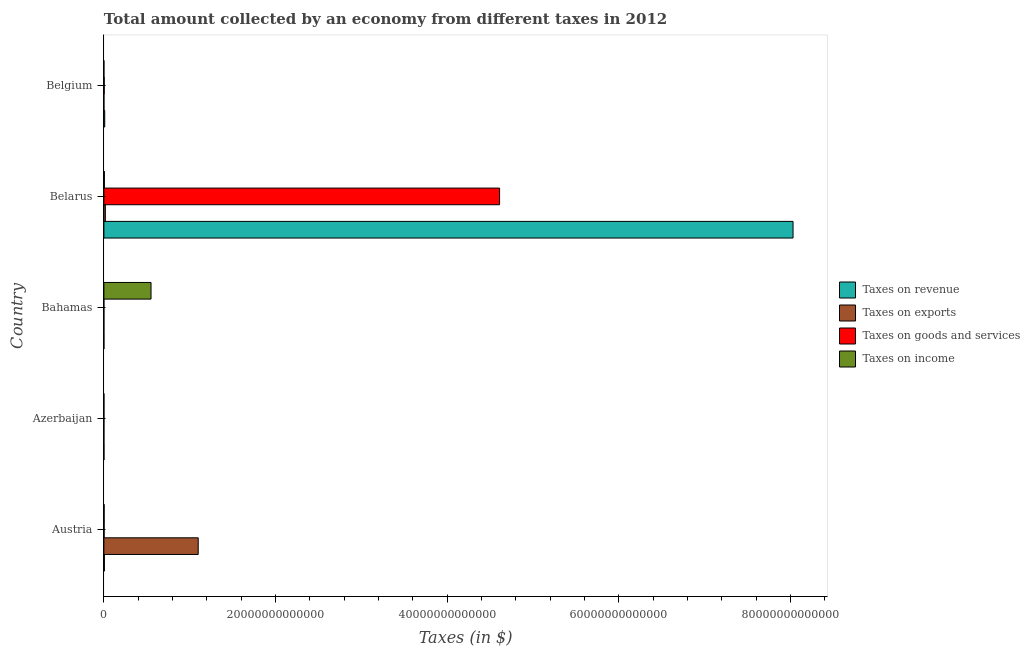How many different coloured bars are there?
Offer a very short reply. 4. What is the label of the 3rd group of bars from the top?
Provide a succinct answer. Bahamas. What is the amount collected as tax on goods in Belgium?
Offer a terse response. 3.81e+1. Across all countries, what is the maximum amount collected as tax on revenue?
Offer a terse response. 8.03e+13. Across all countries, what is the minimum amount collected as tax on exports?
Give a very brief answer. 2.26e+06. In which country was the amount collected as tax on revenue maximum?
Provide a succinct answer. Belarus. In which country was the amount collected as tax on revenue minimum?
Offer a very short reply. Bahamas. What is the total amount collected as tax on exports in the graph?
Your response must be concise. 1.12e+13. What is the difference between the amount collected as tax on revenue in Belarus and that in Belgium?
Your answer should be very brief. 8.02e+13. What is the difference between the amount collected as tax on income in Austria and the amount collected as tax on revenue in Bahamas?
Ensure brevity in your answer.  2.57e+1. What is the average amount collected as tax on revenue per country?
Make the answer very short. 1.61e+13. What is the difference between the amount collected as tax on exports and amount collected as tax on goods in Belarus?
Offer a very short reply. -4.59e+13. In how many countries, is the amount collected as tax on revenue greater than 72000000000000 $?
Offer a terse response. 1. What is the ratio of the amount collected as tax on income in Austria to that in Belarus?
Ensure brevity in your answer.  0.48. What is the difference between the highest and the second highest amount collected as tax on goods?
Your answer should be compact. 4.61e+13. What is the difference between the highest and the lowest amount collected as tax on exports?
Offer a very short reply. 1.10e+13. In how many countries, is the amount collected as tax on goods greater than the average amount collected as tax on goods taken over all countries?
Your answer should be compact. 1. Is the sum of the amount collected as tax on income in Bahamas and Belgium greater than the maximum amount collected as tax on exports across all countries?
Ensure brevity in your answer.  No. Is it the case that in every country, the sum of the amount collected as tax on revenue and amount collected as tax on goods is greater than the sum of amount collected as tax on income and amount collected as tax on exports?
Keep it short and to the point. No. What does the 1st bar from the top in Bahamas represents?
Make the answer very short. Taxes on income. What does the 4th bar from the bottom in Azerbaijan represents?
Offer a very short reply. Taxes on income. Is it the case that in every country, the sum of the amount collected as tax on revenue and amount collected as tax on exports is greater than the amount collected as tax on goods?
Provide a short and direct response. Yes. How many countries are there in the graph?
Provide a succinct answer. 5. What is the difference between two consecutive major ticks on the X-axis?
Provide a short and direct response. 2.00e+13. Does the graph contain any zero values?
Provide a short and direct response. No. Does the graph contain grids?
Your answer should be very brief. No. How many legend labels are there?
Make the answer very short. 4. How are the legend labels stacked?
Ensure brevity in your answer.  Vertical. What is the title of the graph?
Ensure brevity in your answer.  Total amount collected by an economy from different taxes in 2012. Does "Social Protection" appear as one of the legend labels in the graph?
Provide a short and direct response. No. What is the label or title of the X-axis?
Make the answer very short. Taxes (in $). What is the Taxes (in $) of Taxes on revenue in Austria?
Provide a succinct answer. 5.79e+1. What is the Taxes (in $) in Taxes on exports in Austria?
Ensure brevity in your answer.  1.10e+13. What is the Taxes (in $) in Taxes on goods and services in Austria?
Make the answer very short. 2.54e+1. What is the Taxes (in $) in Taxes on income in Austria?
Offer a terse response. 2.70e+1. What is the Taxes (in $) in Taxes on revenue in Azerbaijan?
Provide a succinct answer. 7.00e+09. What is the Taxes (in $) of Taxes on exports in Azerbaijan?
Ensure brevity in your answer.  4.79e+08. What is the Taxes (in $) of Taxes on goods and services in Azerbaijan?
Keep it short and to the point. 3.08e+09. What is the Taxes (in $) in Taxes on income in Azerbaijan?
Keep it short and to the point. 3.07e+09. What is the Taxes (in $) in Taxes on revenue in Bahamas?
Keep it short and to the point. 1.28e+09. What is the Taxes (in $) in Taxes on exports in Bahamas?
Your response must be concise. 2.26e+06. What is the Taxes (in $) in Taxes on goods and services in Bahamas?
Ensure brevity in your answer.  2.09e+08. What is the Taxes (in $) of Taxes on income in Bahamas?
Give a very brief answer. 5.49e+12. What is the Taxes (in $) of Taxes on revenue in Belarus?
Give a very brief answer. 8.03e+13. What is the Taxes (in $) of Taxes on exports in Belarus?
Your answer should be compact. 1.69e+11. What is the Taxes (in $) in Taxes on goods and services in Belarus?
Offer a very short reply. 4.61e+13. What is the Taxes (in $) of Taxes on income in Belarus?
Your answer should be compact. 5.65e+1. What is the Taxes (in $) of Taxes on revenue in Belgium?
Ensure brevity in your answer.  9.65e+1. What is the Taxes (in $) in Taxes on exports in Belgium?
Ensure brevity in your answer.  2.23e+09. What is the Taxes (in $) of Taxes on goods and services in Belgium?
Provide a succinct answer. 3.81e+1. What is the Taxes (in $) in Taxes on income in Belgium?
Offer a terse response. 2.42e+08. Across all countries, what is the maximum Taxes (in $) of Taxes on revenue?
Provide a succinct answer. 8.03e+13. Across all countries, what is the maximum Taxes (in $) in Taxes on exports?
Keep it short and to the point. 1.10e+13. Across all countries, what is the maximum Taxes (in $) of Taxes on goods and services?
Your answer should be compact. 4.61e+13. Across all countries, what is the maximum Taxes (in $) in Taxes on income?
Your answer should be compact. 5.49e+12. Across all countries, what is the minimum Taxes (in $) of Taxes on revenue?
Offer a very short reply. 1.28e+09. Across all countries, what is the minimum Taxes (in $) in Taxes on exports?
Your answer should be very brief. 2.26e+06. Across all countries, what is the minimum Taxes (in $) of Taxes on goods and services?
Your answer should be very brief. 2.09e+08. Across all countries, what is the minimum Taxes (in $) of Taxes on income?
Offer a terse response. 2.42e+08. What is the total Taxes (in $) of Taxes on revenue in the graph?
Give a very brief answer. 8.05e+13. What is the total Taxes (in $) in Taxes on exports in the graph?
Offer a terse response. 1.12e+13. What is the total Taxes (in $) in Taxes on goods and services in the graph?
Provide a short and direct response. 4.62e+13. What is the total Taxes (in $) in Taxes on income in the graph?
Your answer should be very brief. 5.58e+12. What is the difference between the Taxes (in $) in Taxes on revenue in Austria and that in Azerbaijan?
Ensure brevity in your answer.  5.10e+1. What is the difference between the Taxes (in $) of Taxes on exports in Austria and that in Azerbaijan?
Offer a very short reply. 1.10e+13. What is the difference between the Taxes (in $) in Taxes on goods and services in Austria and that in Azerbaijan?
Provide a succinct answer. 2.23e+1. What is the difference between the Taxes (in $) of Taxes on income in Austria and that in Azerbaijan?
Provide a succinct answer. 2.40e+1. What is the difference between the Taxes (in $) in Taxes on revenue in Austria and that in Bahamas?
Your response must be concise. 5.67e+1. What is the difference between the Taxes (in $) of Taxes on exports in Austria and that in Bahamas?
Provide a succinct answer. 1.10e+13. What is the difference between the Taxes (in $) in Taxes on goods and services in Austria and that in Bahamas?
Your response must be concise. 2.52e+1. What is the difference between the Taxes (in $) of Taxes on income in Austria and that in Bahamas?
Your response must be concise. -5.46e+12. What is the difference between the Taxes (in $) of Taxes on revenue in Austria and that in Belarus?
Provide a short and direct response. -8.02e+13. What is the difference between the Taxes (in $) of Taxes on exports in Austria and that in Belarus?
Provide a succinct answer. 1.08e+13. What is the difference between the Taxes (in $) in Taxes on goods and services in Austria and that in Belarus?
Provide a succinct answer. -4.61e+13. What is the difference between the Taxes (in $) of Taxes on income in Austria and that in Belarus?
Provide a succinct answer. -2.95e+1. What is the difference between the Taxes (in $) in Taxes on revenue in Austria and that in Belgium?
Make the answer very short. -3.86e+1. What is the difference between the Taxes (in $) in Taxes on exports in Austria and that in Belgium?
Your answer should be very brief. 1.10e+13. What is the difference between the Taxes (in $) of Taxes on goods and services in Austria and that in Belgium?
Offer a terse response. -1.27e+1. What is the difference between the Taxes (in $) in Taxes on income in Austria and that in Belgium?
Provide a succinct answer. 2.68e+1. What is the difference between the Taxes (in $) of Taxes on revenue in Azerbaijan and that in Bahamas?
Your response must be concise. 5.72e+09. What is the difference between the Taxes (in $) in Taxes on exports in Azerbaijan and that in Bahamas?
Keep it short and to the point. 4.77e+08. What is the difference between the Taxes (in $) of Taxes on goods and services in Azerbaijan and that in Bahamas?
Offer a very short reply. 2.87e+09. What is the difference between the Taxes (in $) in Taxes on income in Azerbaijan and that in Bahamas?
Provide a short and direct response. -5.49e+12. What is the difference between the Taxes (in $) of Taxes on revenue in Azerbaijan and that in Belarus?
Provide a succinct answer. -8.03e+13. What is the difference between the Taxes (in $) of Taxes on exports in Azerbaijan and that in Belarus?
Offer a terse response. -1.69e+11. What is the difference between the Taxes (in $) in Taxes on goods and services in Azerbaijan and that in Belarus?
Offer a terse response. -4.61e+13. What is the difference between the Taxes (in $) in Taxes on income in Azerbaijan and that in Belarus?
Give a very brief answer. -5.35e+1. What is the difference between the Taxes (in $) in Taxes on revenue in Azerbaijan and that in Belgium?
Offer a very short reply. -8.95e+1. What is the difference between the Taxes (in $) of Taxes on exports in Azerbaijan and that in Belgium?
Your answer should be very brief. -1.75e+09. What is the difference between the Taxes (in $) of Taxes on goods and services in Azerbaijan and that in Belgium?
Offer a terse response. -3.51e+1. What is the difference between the Taxes (in $) of Taxes on income in Azerbaijan and that in Belgium?
Offer a terse response. 2.83e+09. What is the difference between the Taxes (in $) of Taxes on revenue in Bahamas and that in Belarus?
Give a very brief answer. -8.03e+13. What is the difference between the Taxes (in $) of Taxes on exports in Bahamas and that in Belarus?
Offer a very short reply. -1.69e+11. What is the difference between the Taxes (in $) of Taxes on goods and services in Bahamas and that in Belarus?
Your response must be concise. -4.61e+13. What is the difference between the Taxes (in $) in Taxes on income in Bahamas and that in Belarus?
Your answer should be very brief. 5.44e+12. What is the difference between the Taxes (in $) of Taxes on revenue in Bahamas and that in Belgium?
Offer a very short reply. -9.52e+1. What is the difference between the Taxes (in $) of Taxes on exports in Bahamas and that in Belgium?
Provide a succinct answer. -2.22e+09. What is the difference between the Taxes (in $) of Taxes on goods and services in Bahamas and that in Belgium?
Offer a terse response. -3.79e+1. What is the difference between the Taxes (in $) of Taxes on income in Bahamas and that in Belgium?
Offer a very short reply. 5.49e+12. What is the difference between the Taxes (in $) in Taxes on revenue in Belarus and that in Belgium?
Provide a succinct answer. 8.02e+13. What is the difference between the Taxes (in $) in Taxes on exports in Belarus and that in Belgium?
Give a very brief answer. 1.67e+11. What is the difference between the Taxes (in $) of Taxes on goods and services in Belarus and that in Belgium?
Your answer should be compact. 4.61e+13. What is the difference between the Taxes (in $) of Taxes on income in Belarus and that in Belgium?
Give a very brief answer. 5.63e+1. What is the difference between the Taxes (in $) in Taxes on revenue in Austria and the Taxes (in $) in Taxes on exports in Azerbaijan?
Give a very brief answer. 5.75e+1. What is the difference between the Taxes (in $) of Taxes on revenue in Austria and the Taxes (in $) of Taxes on goods and services in Azerbaijan?
Give a very brief answer. 5.49e+1. What is the difference between the Taxes (in $) in Taxes on revenue in Austria and the Taxes (in $) in Taxes on income in Azerbaijan?
Make the answer very short. 5.49e+1. What is the difference between the Taxes (in $) in Taxes on exports in Austria and the Taxes (in $) in Taxes on goods and services in Azerbaijan?
Provide a short and direct response. 1.10e+13. What is the difference between the Taxes (in $) in Taxes on exports in Austria and the Taxes (in $) in Taxes on income in Azerbaijan?
Offer a very short reply. 1.10e+13. What is the difference between the Taxes (in $) in Taxes on goods and services in Austria and the Taxes (in $) in Taxes on income in Azerbaijan?
Ensure brevity in your answer.  2.23e+1. What is the difference between the Taxes (in $) of Taxes on revenue in Austria and the Taxes (in $) of Taxes on exports in Bahamas?
Your answer should be compact. 5.79e+1. What is the difference between the Taxes (in $) in Taxes on revenue in Austria and the Taxes (in $) in Taxes on goods and services in Bahamas?
Make the answer very short. 5.77e+1. What is the difference between the Taxes (in $) of Taxes on revenue in Austria and the Taxes (in $) of Taxes on income in Bahamas?
Offer a terse response. -5.43e+12. What is the difference between the Taxes (in $) in Taxes on exports in Austria and the Taxes (in $) in Taxes on goods and services in Bahamas?
Make the answer very short. 1.10e+13. What is the difference between the Taxes (in $) of Taxes on exports in Austria and the Taxes (in $) of Taxes on income in Bahamas?
Provide a short and direct response. 5.50e+12. What is the difference between the Taxes (in $) of Taxes on goods and services in Austria and the Taxes (in $) of Taxes on income in Bahamas?
Make the answer very short. -5.47e+12. What is the difference between the Taxes (in $) of Taxes on revenue in Austria and the Taxes (in $) of Taxes on exports in Belarus?
Provide a succinct answer. -1.11e+11. What is the difference between the Taxes (in $) in Taxes on revenue in Austria and the Taxes (in $) in Taxes on goods and services in Belarus?
Offer a terse response. -4.60e+13. What is the difference between the Taxes (in $) in Taxes on revenue in Austria and the Taxes (in $) in Taxes on income in Belarus?
Make the answer very short. 1.41e+09. What is the difference between the Taxes (in $) of Taxes on exports in Austria and the Taxes (in $) of Taxes on goods and services in Belarus?
Provide a succinct answer. -3.51e+13. What is the difference between the Taxes (in $) of Taxes on exports in Austria and the Taxes (in $) of Taxes on income in Belarus?
Make the answer very short. 1.09e+13. What is the difference between the Taxes (in $) in Taxes on goods and services in Austria and the Taxes (in $) in Taxes on income in Belarus?
Offer a very short reply. -3.11e+1. What is the difference between the Taxes (in $) in Taxes on revenue in Austria and the Taxes (in $) in Taxes on exports in Belgium?
Your answer should be very brief. 5.57e+1. What is the difference between the Taxes (in $) of Taxes on revenue in Austria and the Taxes (in $) of Taxes on goods and services in Belgium?
Provide a short and direct response. 1.98e+1. What is the difference between the Taxes (in $) in Taxes on revenue in Austria and the Taxes (in $) in Taxes on income in Belgium?
Ensure brevity in your answer.  5.77e+1. What is the difference between the Taxes (in $) of Taxes on exports in Austria and the Taxes (in $) of Taxes on goods and services in Belgium?
Keep it short and to the point. 1.10e+13. What is the difference between the Taxes (in $) of Taxes on exports in Austria and the Taxes (in $) of Taxes on income in Belgium?
Your response must be concise. 1.10e+13. What is the difference between the Taxes (in $) in Taxes on goods and services in Austria and the Taxes (in $) in Taxes on income in Belgium?
Give a very brief answer. 2.52e+1. What is the difference between the Taxes (in $) in Taxes on revenue in Azerbaijan and the Taxes (in $) in Taxes on exports in Bahamas?
Your answer should be compact. 6.99e+09. What is the difference between the Taxes (in $) in Taxes on revenue in Azerbaijan and the Taxes (in $) in Taxes on goods and services in Bahamas?
Make the answer very short. 6.79e+09. What is the difference between the Taxes (in $) in Taxes on revenue in Azerbaijan and the Taxes (in $) in Taxes on income in Bahamas?
Make the answer very short. -5.48e+12. What is the difference between the Taxes (in $) in Taxes on exports in Azerbaijan and the Taxes (in $) in Taxes on goods and services in Bahamas?
Your response must be concise. 2.71e+08. What is the difference between the Taxes (in $) of Taxes on exports in Azerbaijan and the Taxes (in $) of Taxes on income in Bahamas?
Your answer should be very brief. -5.49e+12. What is the difference between the Taxes (in $) in Taxes on goods and services in Azerbaijan and the Taxes (in $) in Taxes on income in Bahamas?
Keep it short and to the point. -5.49e+12. What is the difference between the Taxes (in $) of Taxes on revenue in Azerbaijan and the Taxes (in $) of Taxes on exports in Belarus?
Ensure brevity in your answer.  -1.62e+11. What is the difference between the Taxes (in $) of Taxes on revenue in Azerbaijan and the Taxes (in $) of Taxes on goods and services in Belarus?
Your response must be concise. -4.61e+13. What is the difference between the Taxes (in $) of Taxes on revenue in Azerbaijan and the Taxes (in $) of Taxes on income in Belarus?
Provide a short and direct response. -4.95e+1. What is the difference between the Taxes (in $) of Taxes on exports in Azerbaijan and the Taxes (in $) of Taxes on goods and services in Belarus?
Offer a terse response. -4.61e+13. What is the difference between the Taxes (in $) of Taxes on exports in Azerbaijan and the Taxes (in $) of Taxes on income in Belarus?
Offer a terse response. -5.61e+1. What is the difference between the Taxes (in $) in Taxes on goods and services in Azerbaijan and the Taxes (in $) in Taxes on income in Belarus?
Your answer should be very brief. -5.35e+1. What is the difference between the Taxes (in $) in Taxes on revenue in Azerbaijan and the Taxes (in $) in Taxes on exports in Belgium?
Provide a succinct answer. 4.77e+09. What is the difference between the Taxes (in $) in Taxes on revenue in Azerbaijan and the Taxes (in $) in Taxes on goods and services in Belgium?
Ensure brevity in your answer.  -3.11e+1. What is the difference between the Taxes (in $) in Taxes on revenue in Azerbaijan and the Taxes (in $) in Taxes on income in Belgium?
Ensure brevity in your answer.  6.75e+09. What is the difference between the Taxes (in $) in Taxes on exports in Azerbaijan and the Taxes (in $) in Taxes on goods and services in Belgium?
Your answer should be very brief. -3.77e+1. What is the difference between the Taxes (in $) in Taxes on exports in Azerbaijan and the Taxes (in $) in Taxes on income in Belgium?
Provide a succinct answer. 2.38e+08. What is the difference between the Taxes (in $) of Taxes on goods and services in Azerbaijan and the Taxes (in $) of Taxes on income in Belgium?
Ensure brevity in your answer.  2.84e+09. What is the difference between the Taxes (in $) of Taxes on revenue in Bahamas and the Taxes (in $) of Taxes on exports in Belarus?
Make the answer very short. -1.68e+11. What is the difference between the Taxes (in $) in Taxes on revenue in Bahamas and the Taxes (in $) in Taxes on goods and services in Belarus?
Your answer should be very brief. -4.61e+13. What is the difference between the Taxes (in $) of Taxes on revenue in Bahamas and the Taxes (in $) of Taxes on income in Belarus?
Offer a terse response. -5.53e+1. What is the difference between the Taxes (in $) of Taxes on exports in Bahamas and the Taxes (in $) of Taxes on goods and services in Belarus?
Make the answer very short. -4.61e+13. What is the difference between the Taxes (in $) in Taxes on exports in Bahamas and the Taxes (in $) in Taxes on income in Belarus?
Make the answer very short. -5.65e+1. What is the difference between the Taxes (in $) in Taxes on goods and services in Bahamas and the Taxes (in $) in Taxes on income in Belarus?
Offer a very short reply. -5.63e+1. What is the difference between the Taxes (in $) in Taxes on revenue in Bahamas and the Taxes (in $) in Taxes on exports in Belgium?
Your answer should be compact. -9.49e+08. What is the difference between the Taxes (in $) of Taxes on revenue in Bahamas and the Taxes (in $) of Taxes on goods and services in Belgium?
Your answer should be very brief. -3.69e+1. What is the difference between the Taxes (in $) in Taxes on revenue in Bahamas and the Taxes (in $) in Taxes on income in Belgium?
Make the answer very short. 1.03e+09. What is the difference between the Taxes (in $) in Taxes on exports in Bahamas and the Taxes (in $) in Taxes on goods and services in Belgium?
Offer a terse response. -3.81e+1. What is the difference between the Taxes (in $) in Taxes on exports in Bahamas and the Taxes (in $) in Taxes on income in Belgium?
Make the answer very short. -2.39e+08. What is the difference between the Taxes (in $) in Taxes on goods and services in Bahamas and the Taxes (in $) in Taxes on income in Belgium?
Offer a terse response. -3.30e+07. What is the difference between the Taxes (in $) of Taxes on revenue in Belarus and the Taxes (in $) of Taxes on exports in Belgium?
Give a very brief answer. 8.03e+13. What is the difference between the Taxes (in $) of Taxes on revenue in Belarus and the Taxes (in $) of Taxes on goods and services in Belgium?
Make the answer very short. 8.03e+13. What is the difference between the Taxes (in $) of Taxes on revenue in Belarus and the Taxes (in $) of Taxes on income in Belgium?
Your answer should be very brief. 8.03e+13. What is the difference between the Taxes (in $) of Taxes on exports in Belarus and the Taxes (in $) of Taxes on goods and services in Belgium?
Provide a short and direct response. 1.31e+11. What is the difference between the Taxes (in $) in Taxes on exports in Belarus and the Taxes (in $) in Taxes on income in Belgium?
Offer a very short reply. 1.69e+11. What is the difference between the Taxes (in $) in Taxes on goods and services in Belarus and the Taxes (in $) in Taxes on income in Belgium?
Offer a very short reply. 4.61e+13. What is the average Taxes (in $) of Taxes on revenue per country?
Your answer should be very brief. 1.61e+13. What is the average Taxes (in $) of Taxes on exports per country?
Provide a short and direct response. 2.23e+12. What is the average Taxes (in $) in Taxes on goods and services per country?
Offer a very short reply. 9.23e+12. What is the average Taxes (in $) of Taxes on income per country?
Provide a short and direct response. 1.12e+12. What is the difference between the Taxes (in $) in Taxes on revenue and Taxes (in $) in Taxes on exports in Austria?
Offer a very short reply. -1.09e+13. What is the difference between the Taxes (in $) in Taxes on revenue and Taxes (in $) in Taxes on goods and services in Austria?
Offer a very short reply. 3.25e+1. What is the difference between the Taxes (in $) of Taxes on revenue and Taxes (in $) of Taxes on income in Austria?
Provide a short and direct response. 3.09e+1. What is the difference between the Taxes (in $) in Taxes on exports and Taxes (in $) in Taxes on goods and services in Austria?
Provide a succinct answer. 1.10e+13. What is the difference between the Taxes (in $) of Taxes on exports and Taxes (in $) of Taxes on income in Austria?
Make the answer very short. 1.10e+13. What is the difference between the Taxes (in $) in Taxes on goods and services and Taxes (in $) in Taxes on income in Austria?
Your answer should be compact. -1.62e+09. What is the difference between the Taxes (in $) in Taxes on revenue and Taxes (in $) in Taxes on exports in Azerbaijan?
Provide a succinct answer. 6.52e+09. What is the difference between the Taxes (in $) in Taxes on revenue and Taxes (in $) in Taxes on goods and services in Azerbaijan?
Your answer should be very brief. 3.92e+09. What is the difference between the Taxes (in $) of Taxes on revenue and Taxes (in $) of Taxes on income in Azerbaijan?
Your answer should be compact. 3.92e+09. What is the difference between the Taxes (in $) in Taxes on exports and Taxes (in $) in Taxes on goods and services in Azerbaijan?
Keep it short and to the point. -2.60e+09. What is the difference between the Taxes (in $) in Taxes on exports and Taxes (in $) in Taxes on income in Azerbaijan?
Ensure brevity in your answer.  -2.59e+09. What is the difference between the Taxes (in $) of Taxes on goods and services and Taxes (in $) of Taxes on income in Azerbaijan?
Offer a very short reply. 7.40e+06. What is the difference between the Taxes (in $) in Taxes on revenue and Taxes (in $) in Taxes on exports in Bahamas?
Offer a terse response. 1.27e+09. What is the difference between the Taxes (in $) of Taxes on revenue and Taxes (in $) of Taxes on goods and services in Bahamas?
Your response must be concise. 1.07e+09. What is the difference between the Taxes (in $) in Taxes on revenue and Taxes (in $) in Taxes on income in Bahamas?
Provide a succinct answer. -5.49e+12. What is the difference between the Taxes (in $) of Taxes on exports and Taxes (in $) of Taxes on goods and services in Bahamas?
Your response must be concise. -2.06e+08. What is the difference between the Taxes (in $) of Taxes on exports and Taxes (in $) of Taxes on income in Bahamas?
Ensure brevity in your answer.  -5.49e+12. What is the difference between the Taxes (in $) of Taxes on goods and services and Taxes (in $) of Taxes on income in Bahamas?
Make the answer very short. -5.49e+12. What is the difference between the Taxes (in $) of Taxes on revenue and Taxes (in $) of Taxes on exports in Belarus?
Make the answer very short. 8.01e+13. What is the difference between the Taxes (in $) in Taxes on revenue and Taxes (in $) in Taxes on goods and services in Belarus?
Keep it short and to the point. 3.42e+13. What is the difference between the Taxes (in $) of Taxes on revenue and Taxes (in $) of Taxes on income in Belarus?
Provide a succinct answer. 8.02e+13. What is the difference between the Taxes (in $) in Taxes on exports and Taxes (in $) in Taxes on goods and services in Belarus?
Provide a short and direct response. -4.59e+13. What is the difference between the Taxes (in $) in Taxes on exports and Taxes (in $) in Taxes on income in Belarus?
Your answer should be compact. 1.13e+11. What is the difference between the Taxes (in $) of Taxes on goods and services and Taxes (in $) of Taxes on income in Belarus?
Give a very brief answer. 4.60e+13. What is the difference between the Taxes (in $) in Taxes on revenue and Taxes (in $) in Taxes on exports in Belgium?
Provide a succinct answer. 9.43e+1. What is the difference between the Taxes (in $) in Taxes on revenue and Taxes (in $) in Taxes on goods and services in Belgium?
Give a very brief answer. 5.84e+1. What is the difference between the Taxes (in $) in Taxes on revenue and Taxes (in $) in Taxes on income in Belgium?
Your answer should be compact. 9.63e+1. What is the difference between the Taxes (in $) of Taxes on exports and Taxes (in $) of Taxes on goods and services in Belgium?
Ensure brevity in your answer.  -3.59e+1. What is the difference between the Taxes (in $) in Taxes on exports and Taxes (in $) in Taxes on income in Belgium?
Your response must be concise. 1.98e+09. What is the difference between the Taxes (in $) in Taxes on goods and services and Taxes (in $) in Taxes on income in Belgium?
Make the answer very short. 3.79e+1. What is the ratio of the Taxes (in $) of Taxes on revenue in Austria to that in Azerbaijan?
Your answer should be compact. 8.28. What is the ratio of the Taxes (in $) of Taxes on exports in Austria to that in Azerbaijan?
Keep it short and to the point. 2.29e+04. What is the ratio of the Taxes (in $) in Taxes on goods and services in Austria to that in Azerbaijan?
Make the answer very short. 8.25. What is the ratio of the Taxes (in $) of Taxes on income in Austria to that in Azerbaijan?
Offer a terse response. 8.8. What is the ratio of the Taxes (in $) in Taxes on revenue in Austria to that in Bahamas?
Offer a terse response. 45.39. What is the ratio of the Taxes (in $) of Taxes on exports in Austria to that in Bahamas?
Provide a succinct answer. 4.86e+06. What is the ratio of the Taxes (in $) in Taxes on goods and services in Austria to that in Bahamas?
Give a very brief answer. 121.74. What is the ratio of the Taxes (in $) in Taxes on income in Austria to that in Bahamas?
Keep it short and to the point. 0. What is the ratio of the Taxes (in $) in Taxes on revenue in Austria to that in Belarus?
Your response must be concise. 0. What is the ratio of the Taxes (in $) in Taxes on exports in Austria to that in Belarus?
Your response must be concise. 64.98. What is the ratio of the Taxes (in $) in Taxes on goods and services in Austria to that in Belarus?
Your answer should be compact. 0. What is the ratio of the Taxes (in $) in Taxes on income in Austria to that in Belarus?
Offer a very short reply. 0.48. What is the ratio of the Taxes (in $) in Taxes on revenue in Austria to that in Belgium?
Provide a succinct answer. 0.6. What is the ratio of the Taxes (in $) in Taxes on exports in Austria to that in Belgium?
Give a very brief answer. 4937.15. What is the ratio of the Taxes (in $) of Taxes on goods and services in Austria to that in Belgium?
Your answer should be compact. 0.67. What is the ratio of the Taxes (in $) in Taxes on income in Austria to that in Belgium?
Provide a succinct answer. 111.8. What is the ratio of the Taxes (in $) in Taxes on revenue in Azerbaijan to that in Bahamas?
Make the answer very short. 5.48. What is the ratio of the Taxes (in $) in Taxes on exports in Azerbaijan to that in Bahamas?
Ensure brevity in your answer.  212.1. What is the ratio of the Taxes (in $) in Taxes on goods and services in Azerbaijan to that in Bahamas?
Keep it short and to the point. 14.76. What is the ratio of the Taxes (in $) in Taxes on income in Azerbaijan to that in Bahamas?
Give a very brief answer. 0. What is the ratio of the Taxes (in $) in Taxes on exports in Azerbaijan to that in Belarus?
Provide a succinct answer. 0. What is the ratio of the Taxes (in $) of Taxes on goods and services in Azerbaijan to that in Belarus?
Provide a short and direct response. 0. What is the ratio of the Taxes (in $) of Taxes on income in Azerbaijan to that in Belarus?
Your answer should be very brief. 0.05. What is the ratio of the Taxes (in $) of Taxes on revenue in Azerbaijan to that in Belgium?
Your response must be concise. 0.07. What is the ratio of the Taxes (in $) in Taxes on exports in Azerbaijan to that in Belgium?
Offer a terse response. 0.22. What is the ratio of the Taxes (in $) in Taxes on goods and services in Azerbaijan to that in Belgium?
Offer a very short reply. 0.08. What is the ratio of the Taxes (in $) in Taxes on income in Azerbaijan to that in Belgium?
Provide a succinct answer. 12.71. What is the ratio of the Taxes (in $) of Taxes on revenue in Bahamas to that in Belarus?
Your response must be concise. 0. What is the ratio of the Taxes (in $) of Taxes on exports in Bahamas to that in Belarus?
Offer a terse response. 0. What is the ratio of the Taxes (in $) in Taxes on income in Bahamas to that in Belarus?
Make the answer very short. 97.13. What is the ratio of the Taxes (in $) of Taxes on revenue in Bahamas to that in Belgium?
Ensure brevity in your answer.  0.01. What is the ratio of the Taxes (in $) of Taxes on exports in Bahamas to that in Belgium?
Keep it short and to the point. 0. What is the ratio of the Taxes (in $) of Taxes on goods and services in Bahamas to that in Belgium?
Ensure brevity in your answer.  0.01. What is the ratio of the Taxes (in $) of Taxes on income in Bahamas to that in Belgium?
Give a very brief answer. 2.27e+04. What is the ratio of the Taxes (in $) in Taxes on revenue in Belarus to that in Belgium?
Provide a short and direct response. 832.02. What is the ratio of the Taxes (in $) of Taxes on exports in Belarus to that in Belgium?
Your answer should be compact. 75.98. What is the ratio of the Taxes (in $) of Taxes on goods and services in Belarus to that in Belgium?
Your answer should be compact. 1209.06. What is the ratio of the Taxes (in $) in Taxes on income in Belarus to that in Belgium?
Your answer should be very brief. 233.9. What is the difference between the highest and the second highest Taxes (in $) in Taxes on revenue?
Provide a succinct answer. 8.02e+13. What is the difference between the highest and the second highest Taxes (in $) of Taxes on exports?
Your response must be concise. 1.08e+13. What is the difference between the highest and the second highest Taxes (in $) in Taxes on goods and services?
Your answer should be very brief. 4.61e+13. What is the difference between the highest and the second highest Taxes (in $) in Taxes on income?
Provide a succinct answer. 5.44e+12. What is the difference between the highest and the lowest Taxes (in $) in Taxes on revenue?
Your response must be concise. 8.03e+13. What is the difference between the highest and the lowest Taxes (in $) in Taxes on exports?
Your answer should be very brief. 1.10e+13. What is the difference between the highest and the lowest Taxes (in $) of Taxes on goods and services?
Ensure brevity in your answer.  4.61e+13. What is the difference between the highest and the lowest Taxes (in $) in Taxes on income?
Make the answer very short. 5.49e+12. 